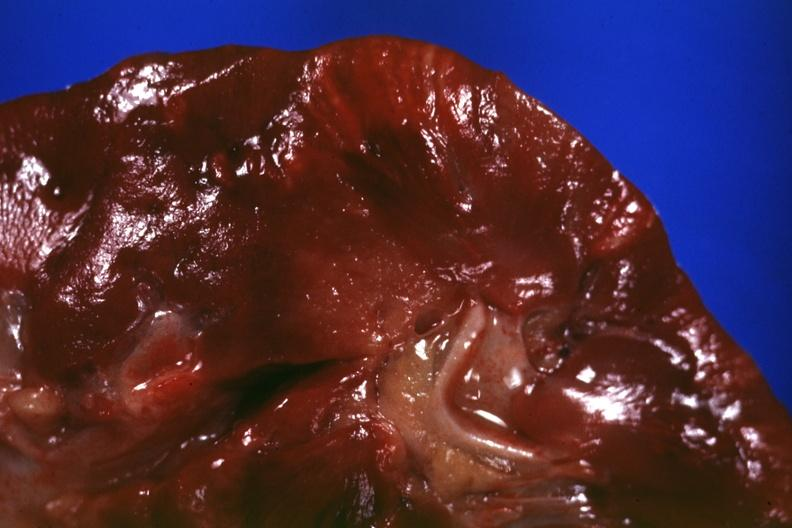where is this?
Answer the question using a single word or phrase. Urinary 